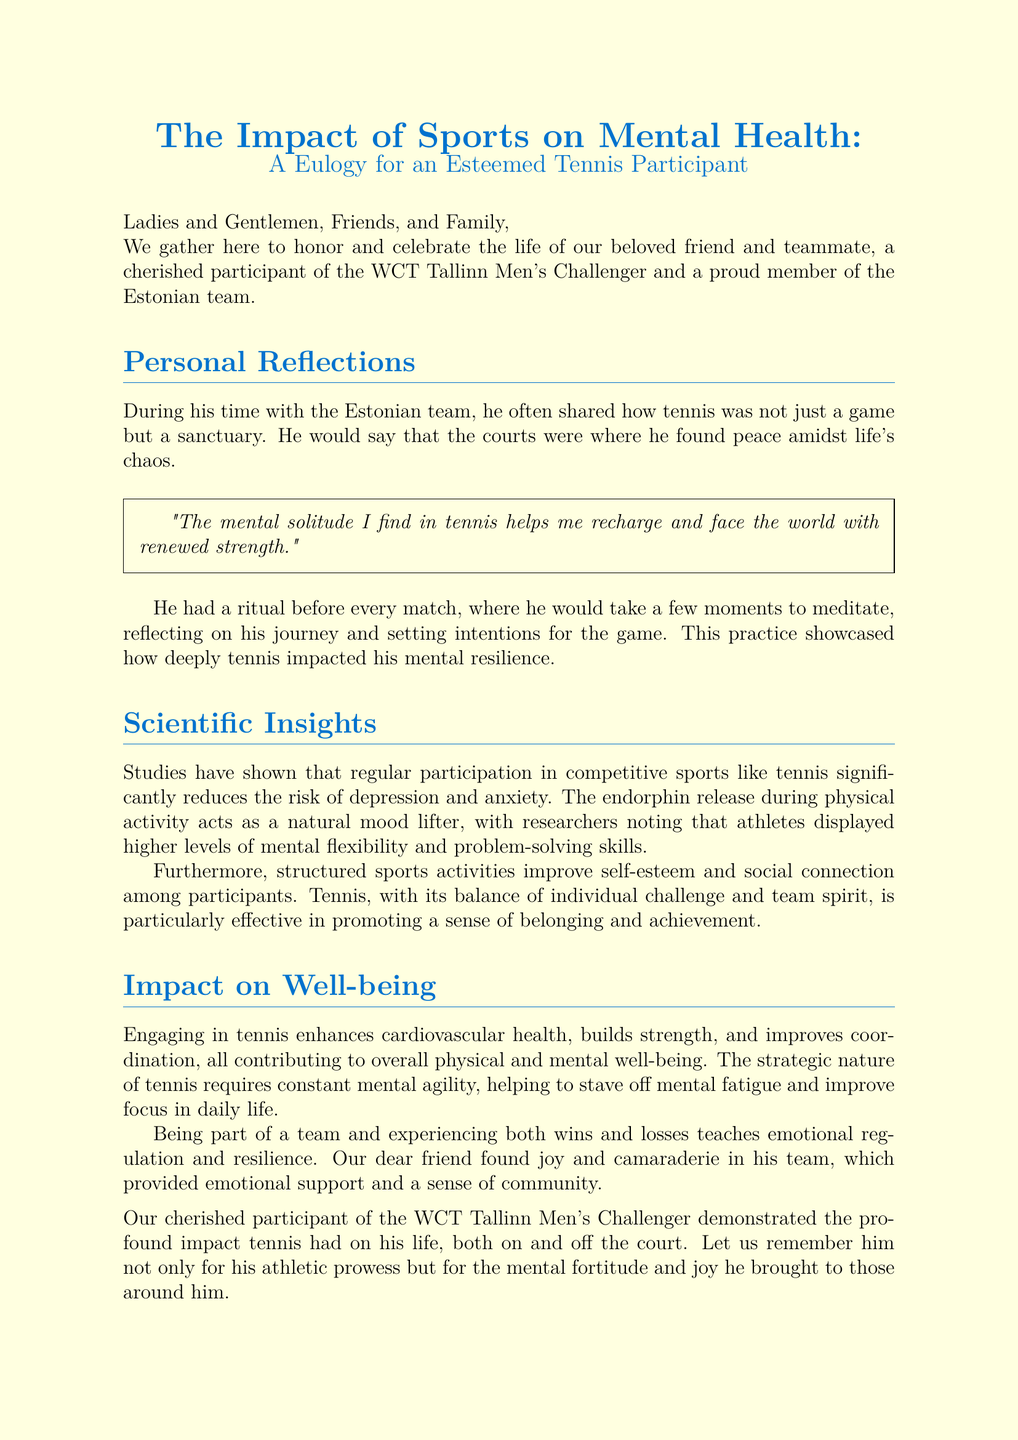What is the title of the document? The title of the document describes its focus and is prominently displayed at the beginning: "The Impact of Sports on Mental Health: A Eulogy for an Esteemed Tennis Participant."
Answer: The Impact of Sports on Mental Health: A Eulogy for an Esteemed Tennis Participant Who is the eulogy dedicated to? The eulogy is honoring a specific individual who participated in a tennis event and was part of the Estonian team.
Answer: A cherished participant of the WCT Tallinn Men's Challenger What sport is discussed in the eulogy? The document centers around an individual’s involvement in a specific competitive sport, which is discussed in detail.
Answer: Tennis What mental health benefit is associated with competitive sports according to the document? The document mentions a specific effect of participating in sports that reduces mental health issues, particularly related to mood.
Answer: Reduced risk of depression and anxiety What ritual did he perform before every match? The eulogy mentions a specific practice the individual engaged in to enhance his mental preparedness prior to competing.
Answer: Meditate What does the document state about tennis and social connection? The eulogy highlights a specific aspect of tennis that contributes to emotional and social health among its players.
Answer: Promoting a sense of belonging and achievement How does the document describe the impact of being part of a team? There is a particular focus on the emotional learning experiences gained through team participation mentioned in the eulogy.
Answer: Teaches emotional regulation and resilience What is a direct quote from the individual about tennis? A specific quote from the individual is included that exhibits his personal reflections on the mental benefits of the sport.
Answer: "The mental solitude I find in tennis helps me recharge and face the world with renewed strength." 